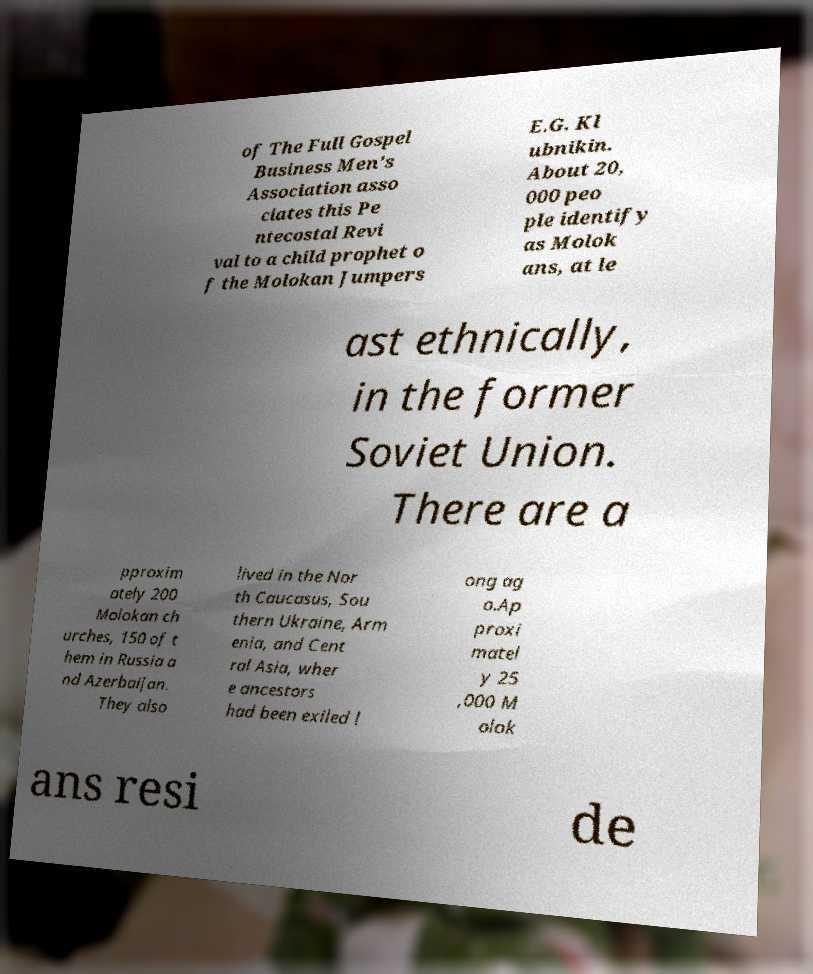Please read and relay the text visible in this image. What does it say? of The Full Gospel Business Men's Association asso ciates this Pe ntecostal Revi val to a child prophet o f the Molokan Jumpers E.G. Kl ubnikin. About 20, 000 peo ple identify as Molok ans, at le ast ethnically, in the former Soviet Union. There are a pproxim ately 200 Molokan ch urches, 150 of t hem in Russia a nd Azerbaijan. They also lived in the Nor th Caucasus, Sou thern Ukraine, Arm enia, and Cent ral Asia, wher e ancestors had been exiled l ong ag o.Ap proxi matel y 25 ,000 M olok ans resi de 